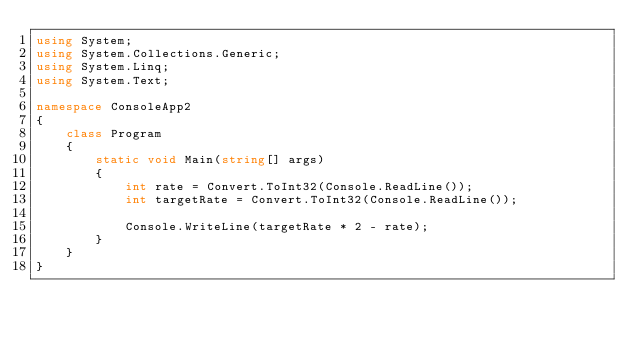Convert code to text. <code><loc_0><loc_0><loc_500><loc_500><_C#_>using System;
using System.Collections.Generic;
using System.Linq;
using System.Text;

namespace ConsoleApp2
{
    class Program
    {
        static void Main(string[] args)
        {
            int rate = Convert.ToInt32(Console.ReadLine());
            int targetRate = Convert.ToInt32(Console.ReadLine());

            Console.WriteLine(targetRate * 2 - rate);
        }
    }
}
</code> 